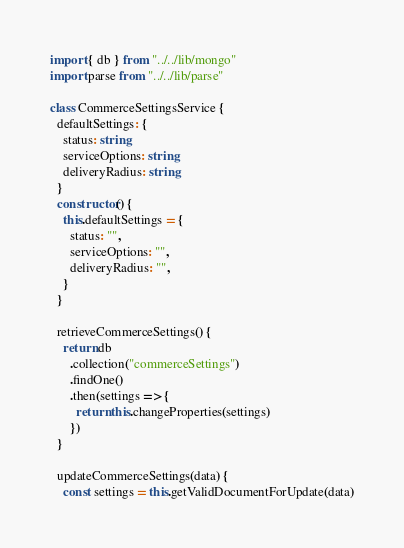<code> <loc_0><loc_0><loc_500><loc_500><_TypeScript_>import { db } from "../../lib/mongo"
import parse from "../../lib/parse"

class CommerceSettingsService {
  defaultSettings: {
    status: string
    serviceOptions: string
    deliveryRadius: string
  }
  constructor() {
    this.defaultSettings = {
      status: "",
      serviceOptions: "",
      deliveryRadius: "",
    }
  }

  retrieveCommerceSettings() {
    return db
      .collection("commerceSettings")
      .findOne()
      .then(settings => {
        return this.changeProperties(settings)
      })
  }

  updateCommerceSettings(data) {
    const settings = this.getValidDocumentForUpdate(data)</code> 